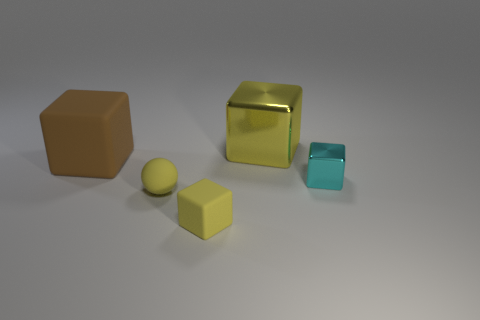Subtract all small rubber blocks. How many blocks are left? 3 Add 4 tiny cubes. How many objects exist? 9 Subtract 2 blocks. How many blocks are left? 2 Subtract all brown blocks. How many blocks are left? 3 Subtract all balls. How many objects are left? 4 Subtract all blue blocks. Subtract all purple cylinders. How many blocks are left? 4 Subtract all cyan balls. How many cyan cubes are left? 1 Subtract all tiny cubes. Subtract all small cyan blocks. How many objects are left? 2 Add 1 large brown things. How many large brown things are left? 2 Add 1 large shiny objects. How many large shiny objects exist? 2 